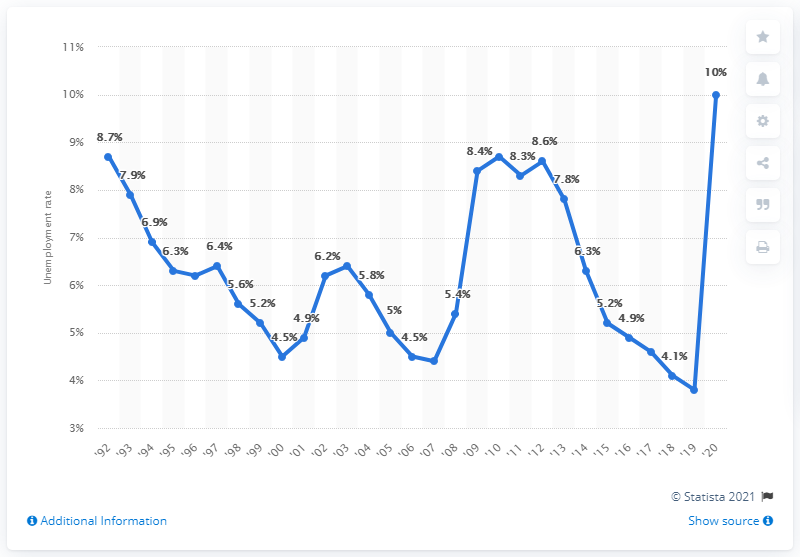Specify some key components in this picture. The previous unemployment rate in New York was 3.8%. In 2020, the unemployment rate in New York was 10%. 